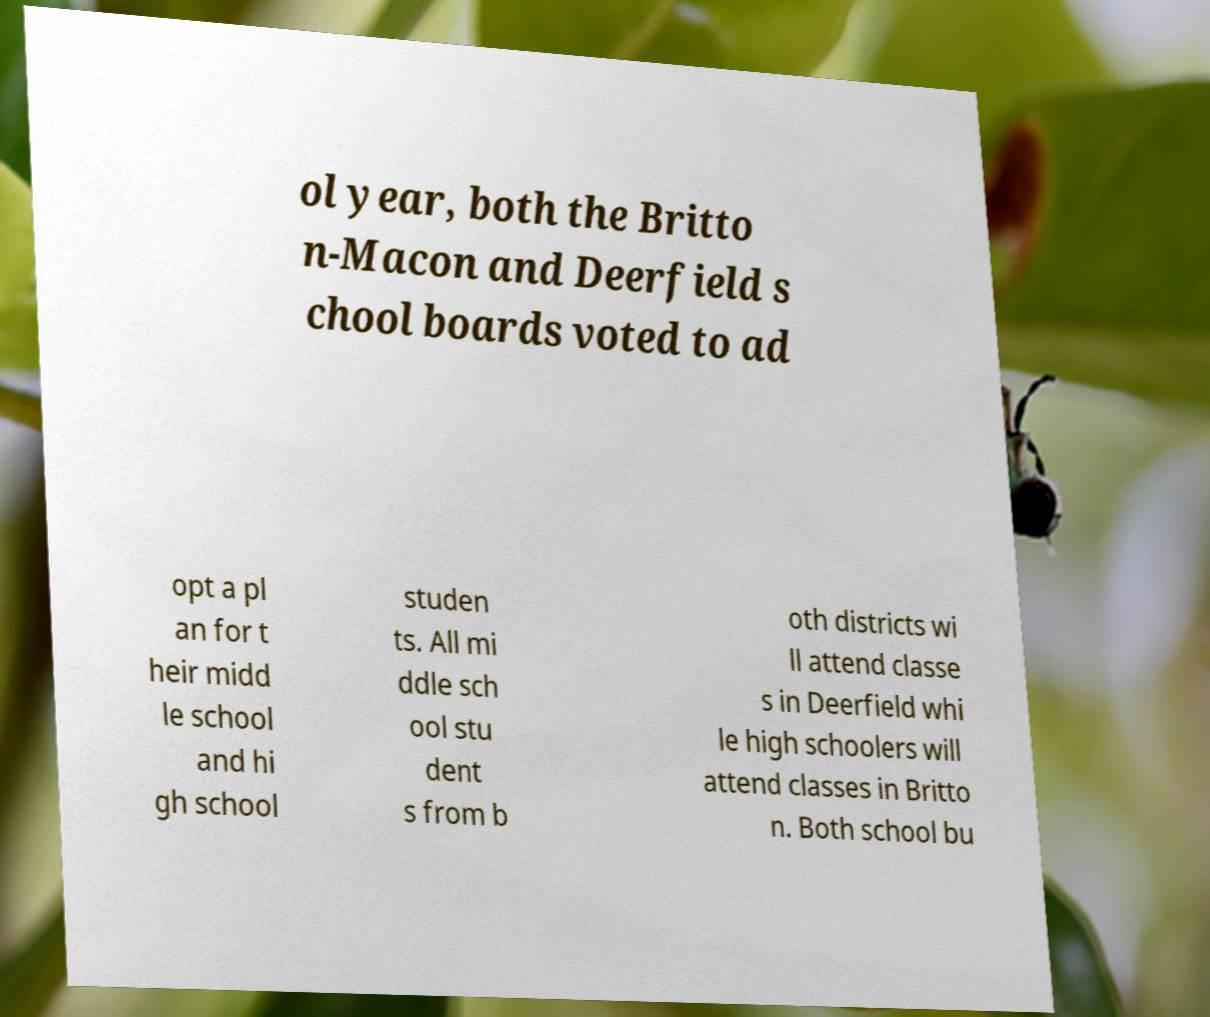For documentation purposes, I need the text within this image transcribed. Could you provide that? ol year, both the Britto n-Macon and Deerfield s chool boards voted to ad opt a pl an for t heir midd le school and hi gh school studen ts. All mi ddle sch ool stu dent s from b oth districts wi ll attend classe s in Deerfield whi le high schoolers will attend classes in Britto n. Both school bu 